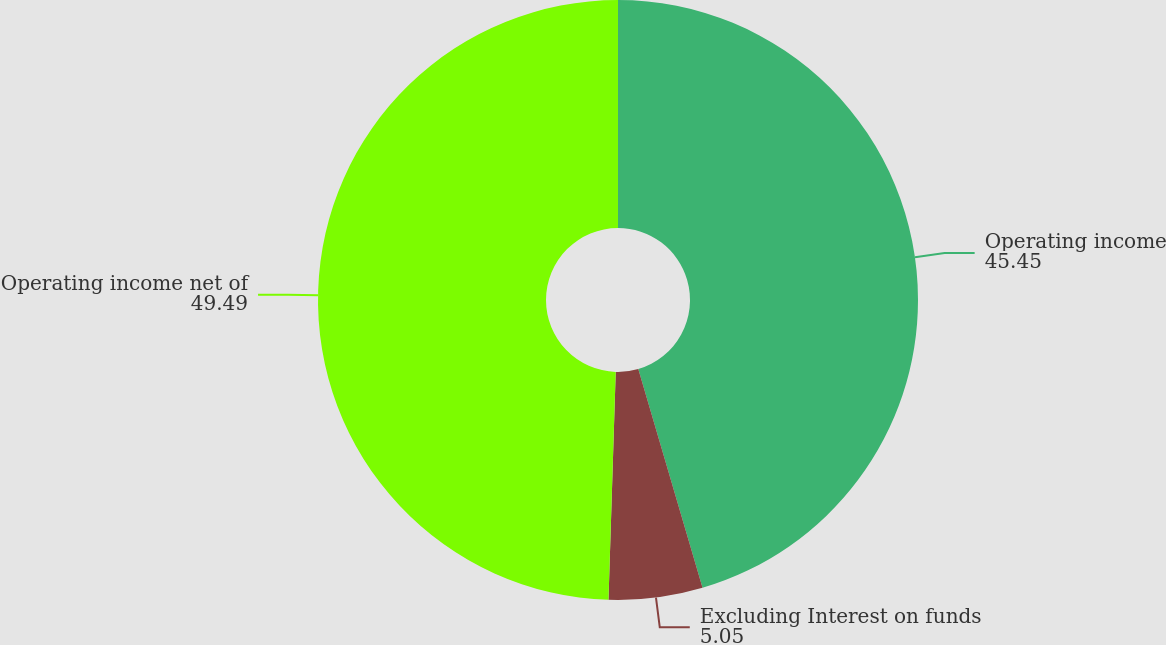Convert chart. <chart><loc_0><loc_0><loc_500><loc_500><pie_chart><fcel>Operating income<fcel>Excluding Interest on funds<fcel>Operating income net of<nl><fcel>45.45%<fcel>5.05%<fcel>49.49%<nl></chart> 